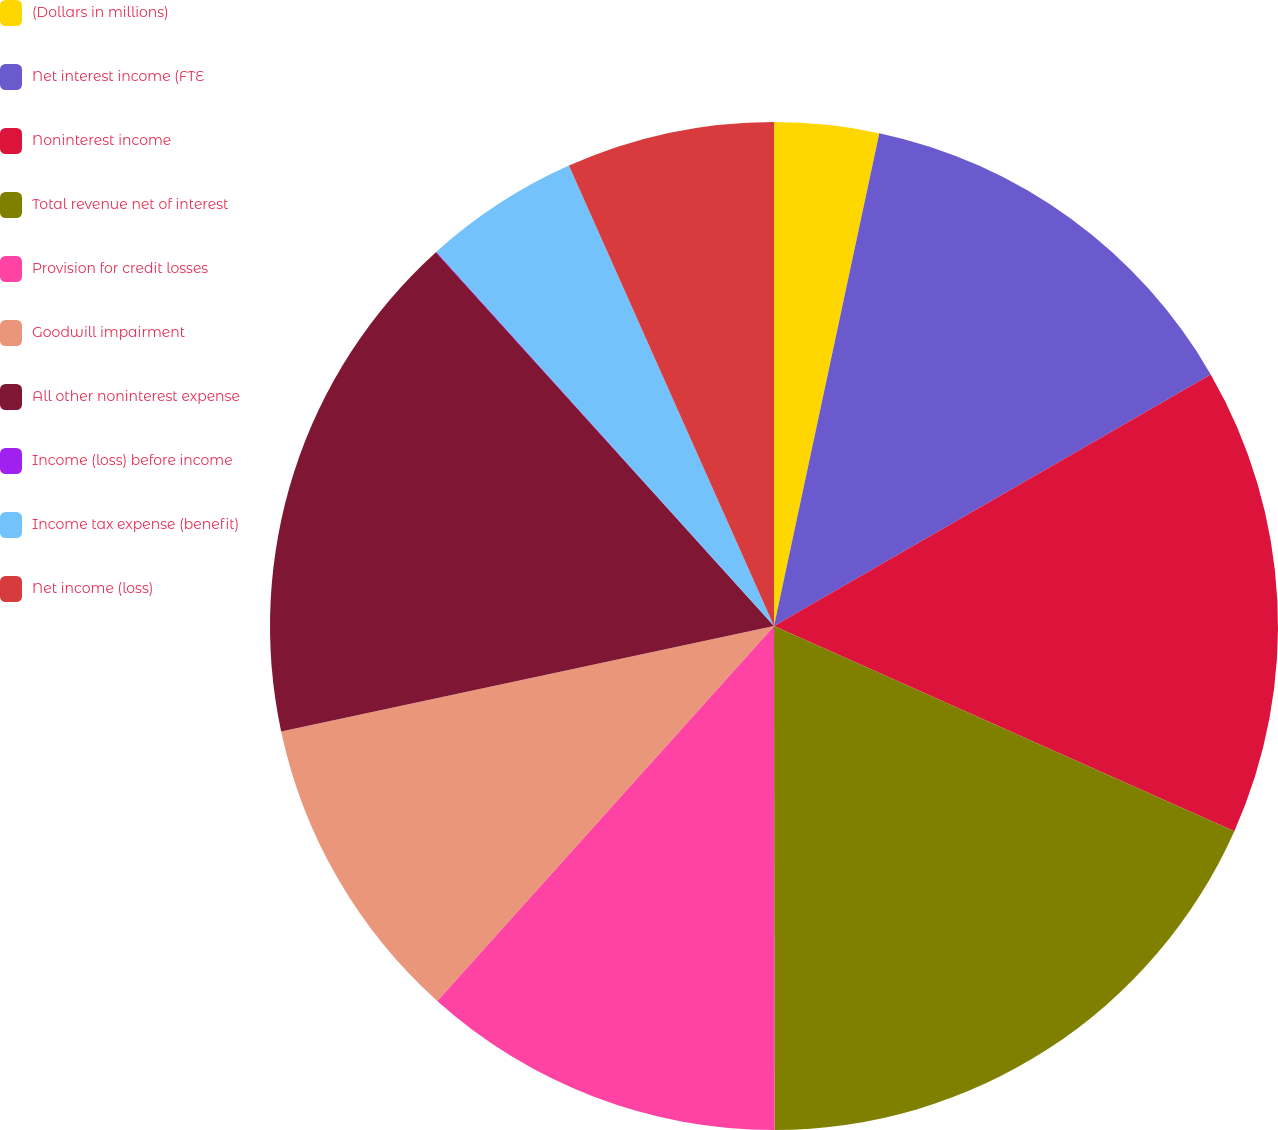Convert chart to OTSL. <chart><loc_0><loc_0><loc_500><loc_500><pie_chart><fcel>(Dollars in millions)<fcel>Net interest income (FTE<fcel>Noninterest income<fcel>Total revenue net of interest<fcel>Provision for credit losses<fcel>Goodwill impairment<fcel>All other noninterest expense<fcel>Income (loss) before income<fcel>Income tax expense (benefit)<fcel>Net income (loss)<nl><fcel>3.35%<fcel>13.33%<fcel>14.99%<fcel>18.31%<fcel>11.66%<fcel>10.0%<fcel>16.65%<fcel>0.02%<fcel>5.01%<fcel>6.67%<nl></chart> 